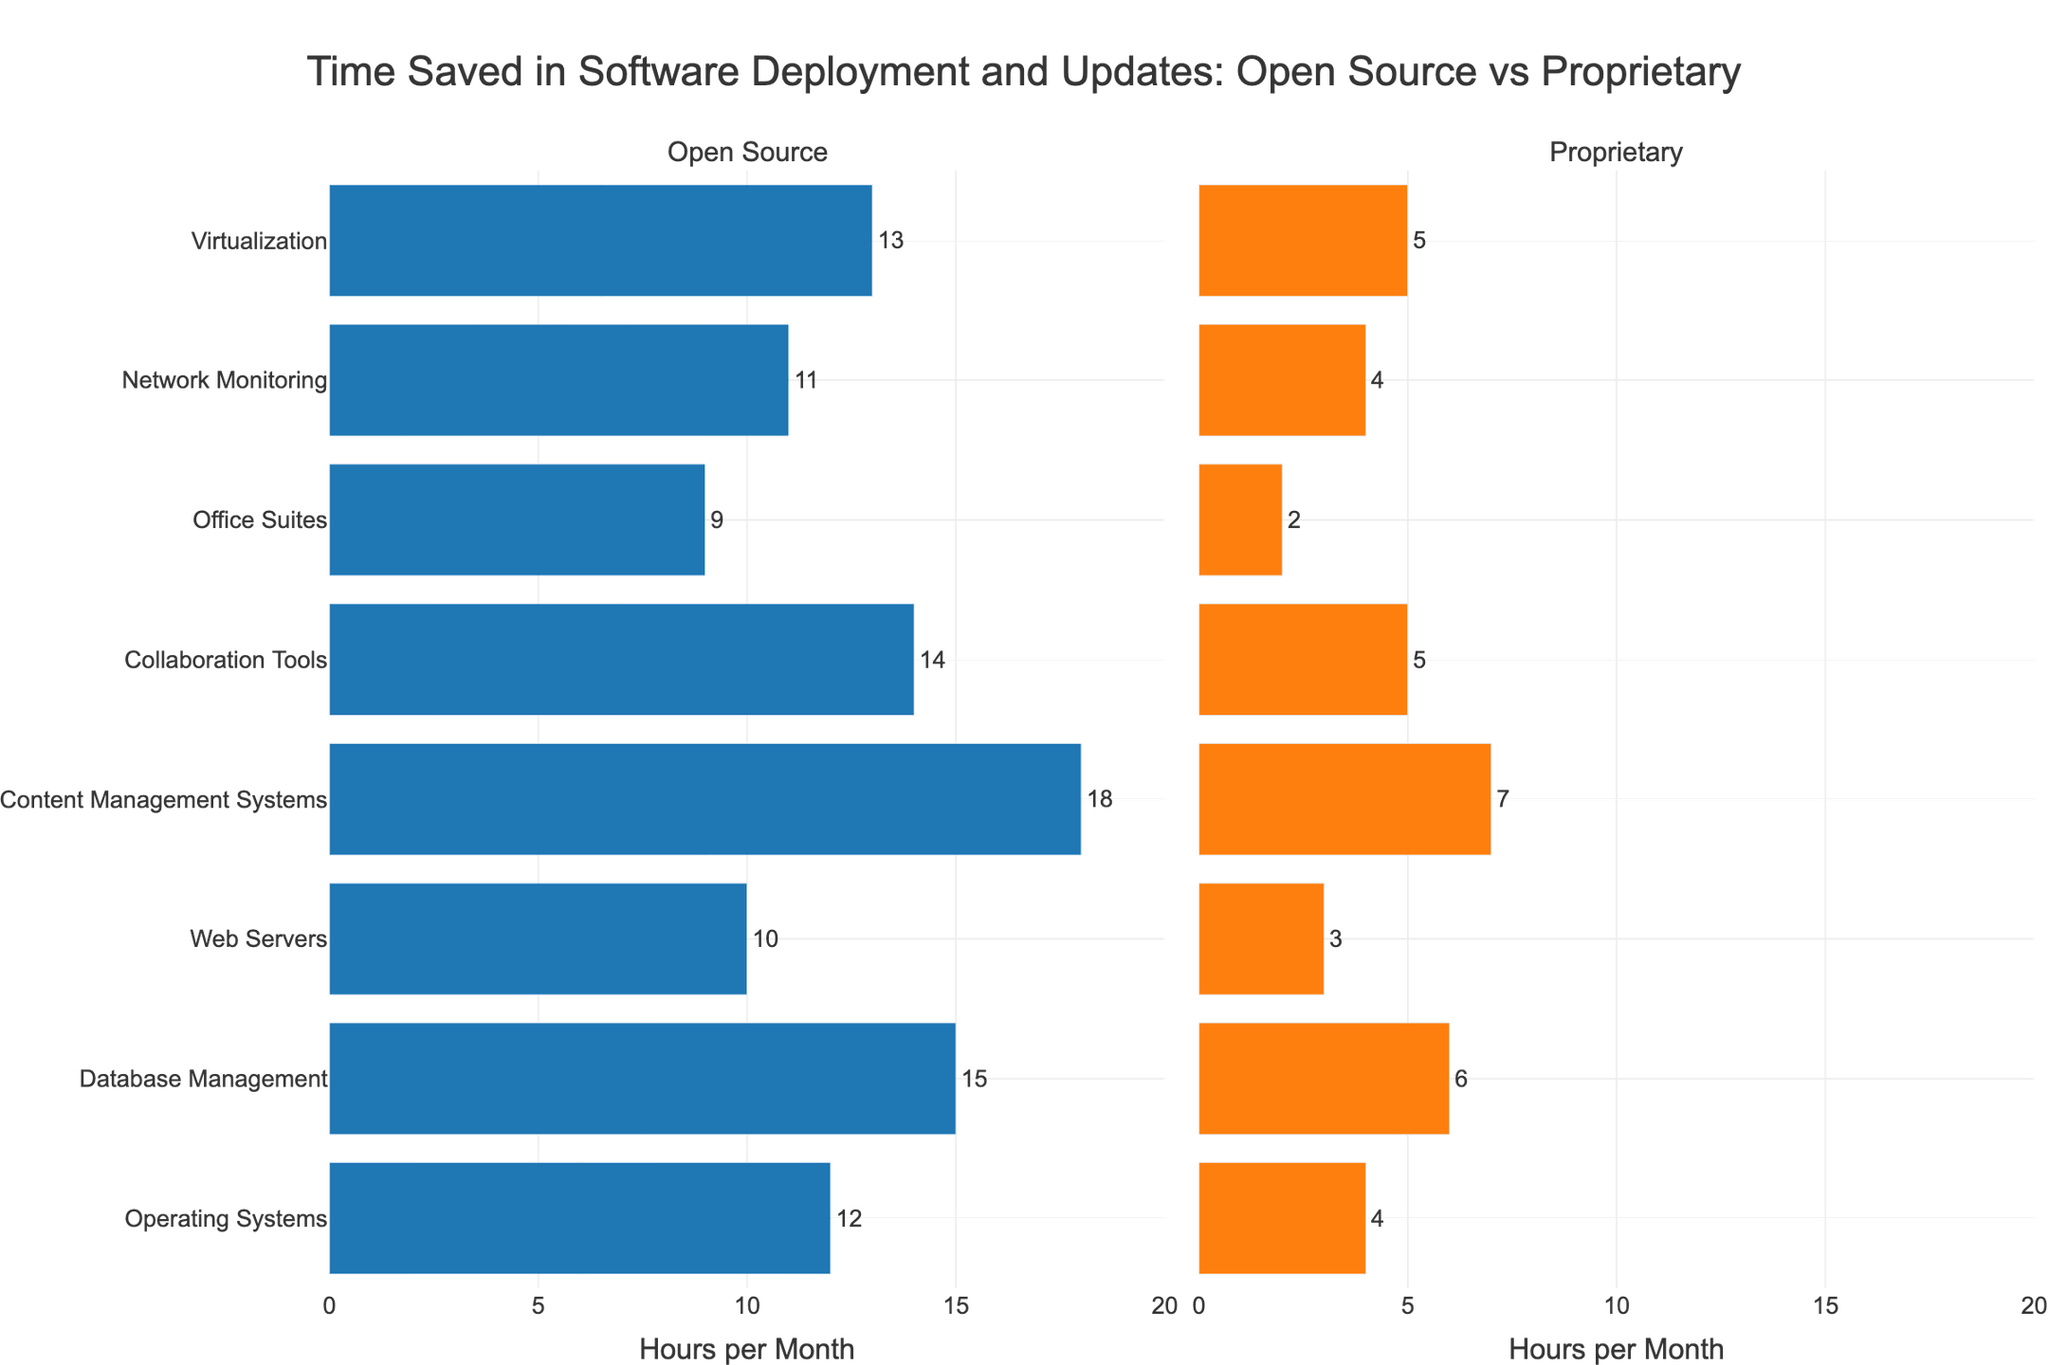Which software type shows the greatest time savings when using open source solutions compared to proprietary solutions? In the Open Source subplot, the bar with the longest length is for Content Management Systems, showing 18 hours saved per month. In the Proprietary subplot, the longest bar is also for Content Management Systems, showing 7 hours saved per month. 18 - 7 = 11 hours. Hence, the greatest time savings is for Content Management Systems.
Answer: Content Management Systems Which software type has the smallest difference in time saved between open source and proprietary solutions? To find the smallest difference, we compare all the pairs of corresponding bars in both subplots. The smallest difference is between Open Source Office Suites (9) and Proprietary Office Suites (2), which is 9 - 2 = 7 hours.
Answer: Office Suites What is the total time saved per month across all open source solutions combined? We sum the values of all open source solutions: 12 (Operating Systems) + 15 (Database Management) + 10 (Web Servers) + 18 (Content Management Systems) + 14 (Collaboration Tools) + 9 (Office Suites) + 11 (Network Monitoring) + 13 (Virtualization) = 102 hours.
Answer: 102 hours What is the average time saved per month for proprietary solutions? We calculate the average by summing the proprietary time savings and dividing by the number of software types: (4 + 6 + 3 + 7 + 5 + 2 + 4 + 5) / 8 = 36 / 8 = 4.5 hours.
Answer: 4.5 hours Which open source solution provides the most time saved compared to its proprietary counterpart? We need to find the difference in time saved between each Open Source and Proprietary pair, where the difference is largest. The largest difference is between Open Source Content Management Systems (18) and Proprietary Content Management Systems (7), with a difference of 18 - 7 = 11 hours.
Answer: Content Management Systems What is the overall difference in time saved between open source and proprietary solutions across all software types? We sum the differences across all pairs: 
(12 - 4) + (15 - 6) + (10 - 3) + (18 - 7) + (14 - 5) + (9 - 2) + (11 - 4) + (13 - 5) 
= 8 + 9 + 7 + 11 + 9 + 7 + 7 + 8 = 66 hours.
Answer: 66 hours Which solution type (open source or proprietary) saves more time in all categories combined? Comparing the total time saved: Open Source (102 hours) vs. Proprietary (36 hours), open source saves more time across all categories.
Answer: Open Source What is the ratio of time saved for open source Content Management Systems compared to proprietary Content Management Systems? The time saved for open source Content Management Systems is 18 hours, and for proprietary Content Management Systems is 7 hours. The ratio is 18 / 7 ≈ 2.57.
Answer: ~2.57 